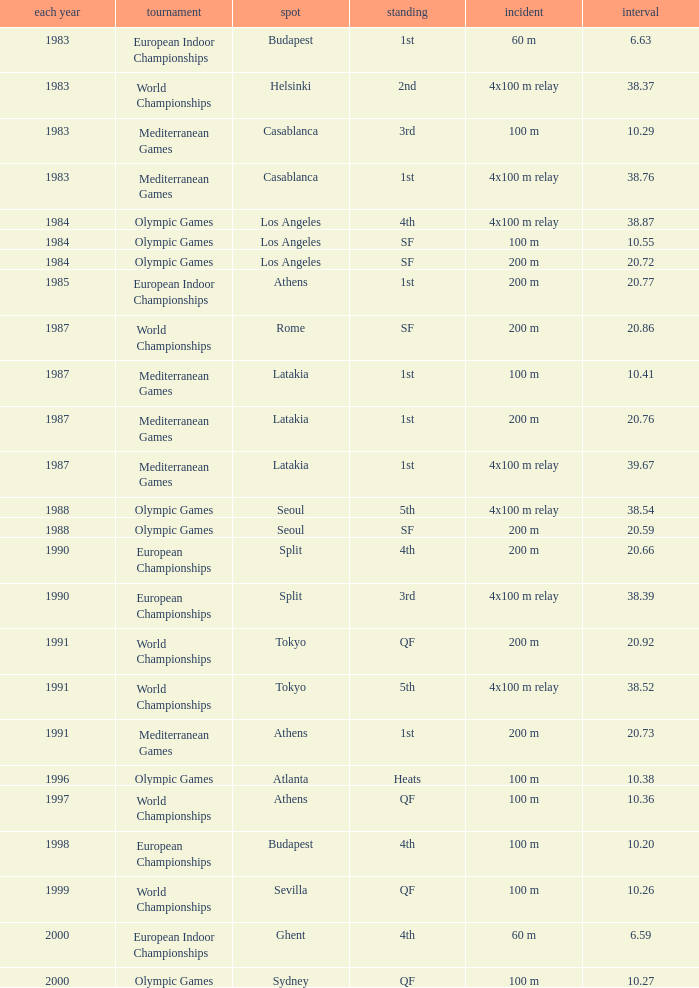What Event has a Position of 1st, a Year of 1983, and a Venue of budapest? 60 m. 